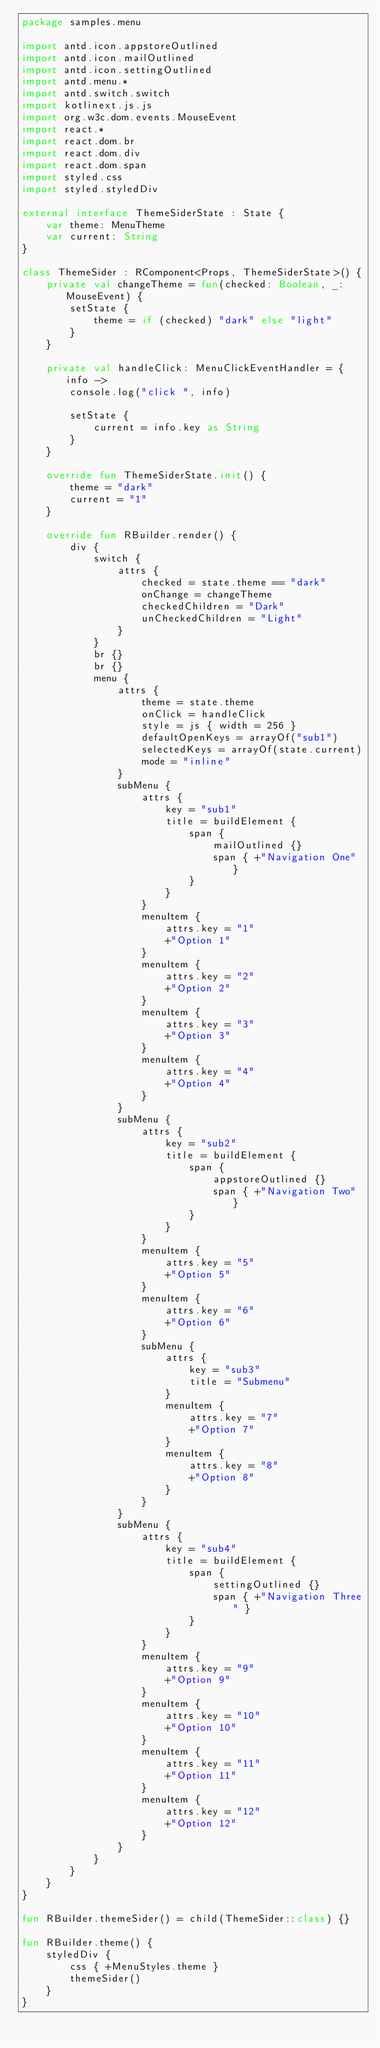<code> <loc_0><loc_0><loc_500><loc_500><_Kotlin_>package samples.menu

import antd.icon.appstoreOutlined
import antd.icon.mailOutlined
import antd.icon.settingOutlined
import antd.menu.*
import antd.switch.switch
import kotlinext.js.js
import org.w3c.dom.events.MouseEvent
import react.*
import react.dom.br
import react.dom.div
import react.dom.span
import styled.css
import styled.styledDiv

external interface ThemeSiderState : State {
    var theme: MenuTheme
    var current: String
}

class ThemeSider : RComponent<Props, ThemeSiderState>() {
    private val changeTheme = fun(checked: Boolean, _: MouseEvent) {
        setState {
            theme = if (checked) "dark" else "light"
        }
    }

    private val handleClick: MenuClickEventHandler = { info ->
        console.log("click ", info)

        setState {
            current = info.key as String
        }
    }

    override fun ThemeSiderState.init() {
        theme = "dark"
        current = "1"
    }

    override fun RBuilder.render() {
        div {
            switch {
                attrs {
                    checked = state.theme == "dark"
                    onChange = changeTheme
                    checkedChildren = "Dark"
                    unCheckedChildren = "Light"
                }
            }
            br {}
            br {}
            menu {
                attrs {
                    theme = state.theme
                    onClick = handleClick
                    style = js { width = 256 }
                    defaultOpenKeys = arrayOf("sub1")
                    selectedKeys = arrayOf(state.current)
                    mode = "inline"
                }
                subMenu {
                    attrs {
                        key = "sub1"
                        title = buildElement {
                            span {
                                mailOutlined {}
                                span { +"Navigation One" }
                            }
                        }
                    }
                    menuItem {
                        attrs.key = "1"
                        +"Option 1"
                    }
                    menuItem {
                        attrs.key = "2"
                        +"Option 2"
                    }
                    menuItem {
                        attrs.key = "3"
                        +"Option 3"
                    }
                    menuItem {
                        attrs.key = "4"
                        +"Option 4"
                    }
                }
                subMenu {
                    attrs {
                        key = "sub2"
                        title = buildElement {
                            span {
                                appstoreOutlined {}
                                span { +"Navigation Two" }
                            }
                        }
                    }
                    menuItem {
                        attrs.key = "5"
                        +"Option 5"
                    }
                    menuItem {
                        attrs.key = "6"
                        +"Option 6"
                    }
                    subMenu {
                        attrs {
                            key = "sub3"
                            title = "Submenu"
                        }
                        menuItem {
                            attrs.key = "7"
                            +"Option 7"
                        }
                        menuItem {
                            attrs.key = "8"
                            +"Option 8"
                        }
                    }
                }
                subMenu {
                    attrs {
                        key = "sub4"
                        title = buildElement {
                            span {
                                settingOutlined {}
                                span { +"Navigation Three" }
                            }
                        }
                    }
                    menuItem {
                        attrs.key = "9"
                        +"Option 9"
                    }
                    menuItem {
                        attrs.key = "10"
                        +"Option 10"
                    }
                    menuItem {
                        attrs.key = "11"
                        +"Option 11"
                    }
                    menuItem {
                        attrs.key = "12"
                        +"Option 12"
                    }
                }
            }
        }
    }
}

fun RBuilder.themeSider() = child(ThemeSider::class) {}

fun RBuilder.theme() {
    styledDiv {
        css { +MenuStyles.theme }
        themeSider()
    }
}
</code> 